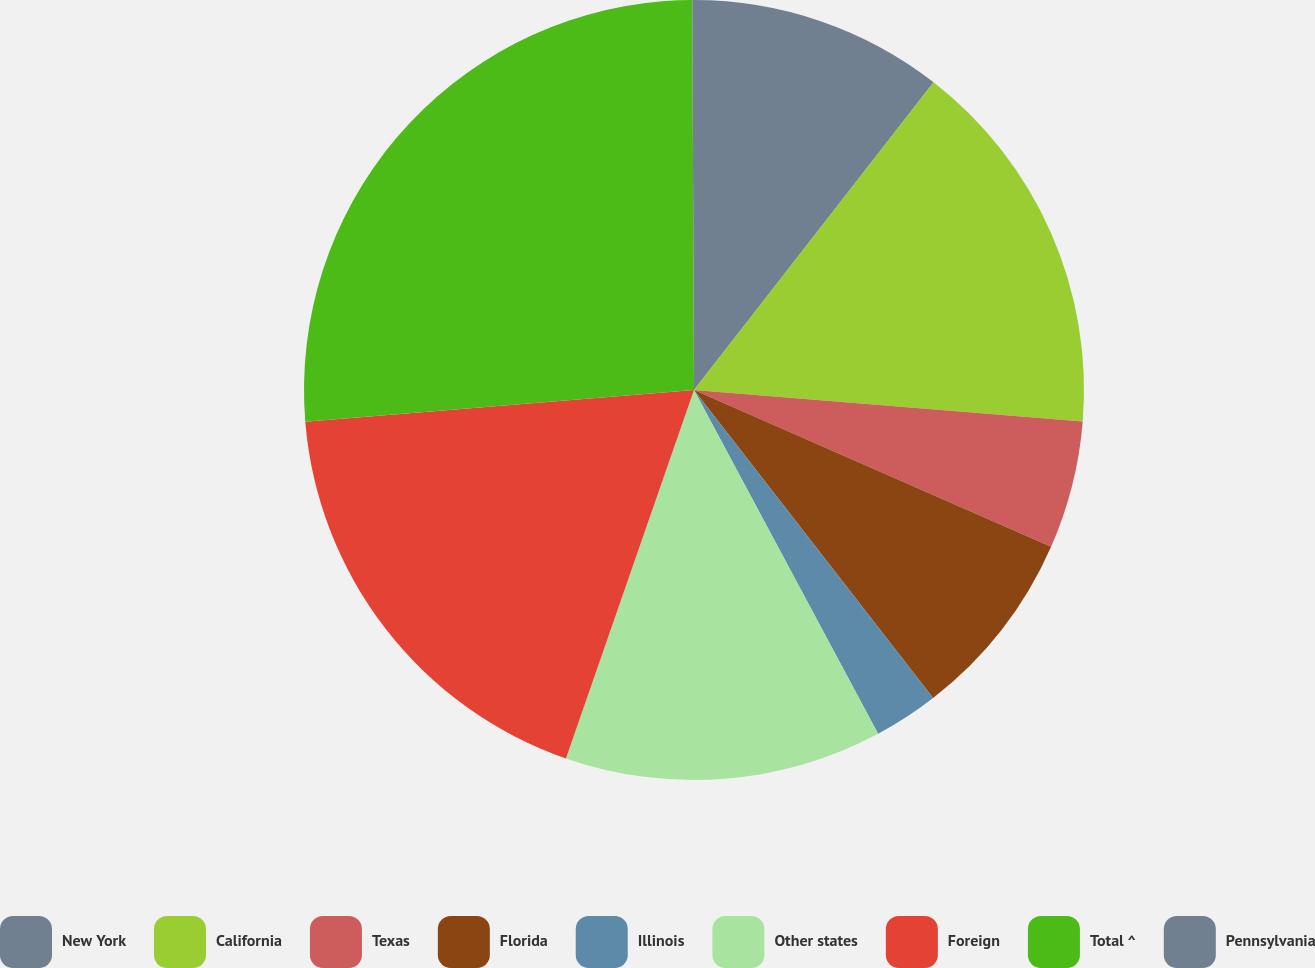<chart> <loc_0><loc_0><loc_500><loc_500><pie_chart><fcel>New York<fcel>California<fcel>Texas<fcel>Florida<fcel>Illinois<fcel>Other states<fcel>Foreign<fcel>Total ^<fcel>Pennsylvania<nl><fcel>10.53%<fcel>15.76%<fcel>5.3%<fcel>7.91%<fcel>2.68%<fcel>13.15%<fcel>18.38%<fcel>26.23%<fcel>0.07%<nl></chart> 